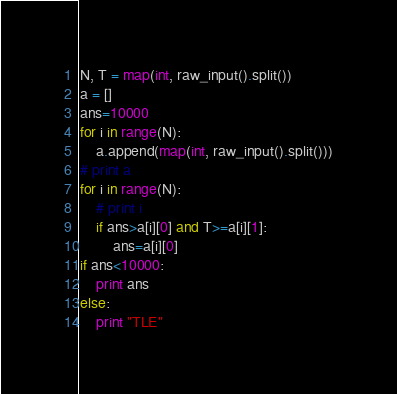<code> <loc_0><loc_0><loc_500><loc_500><_Python_>N, T = map(int, raw_input().split())
a = []
ans=10000
for i in range(N):
    a.append(map(int, raw_input().split()))
# print a
for i in range(N):
    # print i
    if ans>a[i][0] and T>=a[i][1]:
        ans=a[i][0]
if ans<10000:
    print ans
else:
    print "TLE"
</code> 